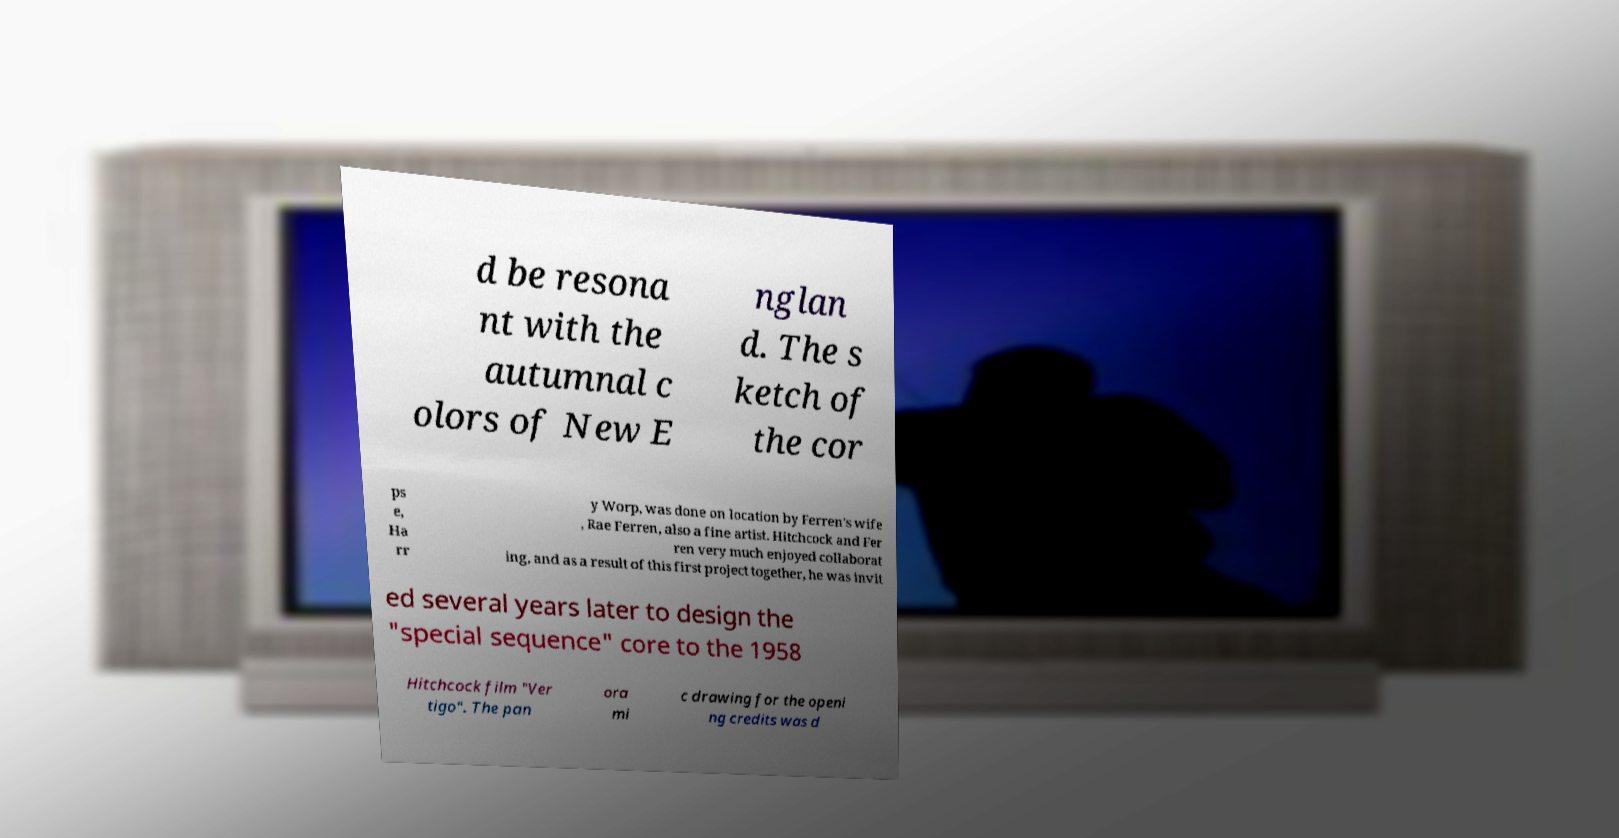Can you read and provide the text displayed in the image?This photo seems to have some interesting text. Can you extract and type it out for me? d be resona nt with the autumnal c olors of New E nglan d. The s ketch of the cor ps e, Ha rr y Worp, was done on location by Ferren's wife , Rae Ferren, also a fine artist. Hitchcock and Fer ren very much enjoyed collaborat ing, and as a result of this first project together, he was invit ed several years later to design the "special sequence" core to the 1958 Hitchcock film "Ver tigo". The pan ora mi c drawing for the openi ng credits was d 